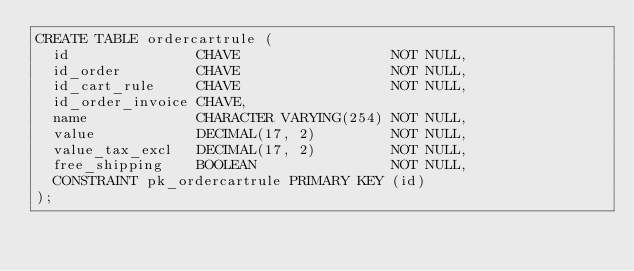<code> <loc_0><loc_0><loc_500><loc_500><_SQL_>CREATE TABLE ordercartrule (
  id               CHAVE                  NOT NULL,
  id_order         CHAVE                  NOT NULL,
  id_cart_rule     CHAVE                  NOT NULL,
  id_order_invoice CHAVE,
  name             CHARACTER VARYING(254) NOT NULL,
  value            DECIMAL(17, 2)         NOT NULL,
  value_tax_excl   DECIMAL(17, 2)         NOT NULL,
  free_shipping    BOOLEAN                NOT NULL,
  CONSTRAINT pk_ordercartrule PRIMARY KEY (id)
);</code> 